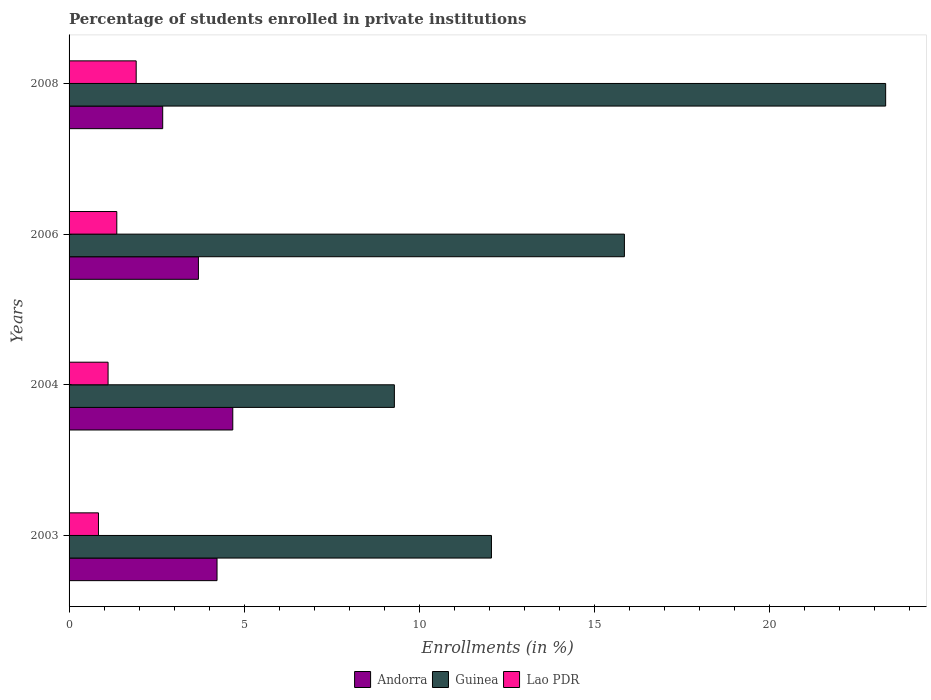Are the number of bars per tick equal to the number of legend labels?
Offer a very short reply. Yes. Are the number of bars on each tick of the Y-axis equal?
Provide a succinct answer. Yes. How many bars are there on the 1st tick from the bottom?
Ensure brevity in your answer.  3. What is the label of the 2nd group of bars from the top?
Your answer should be very brief. 2006. What is the percentage of trained teachers in Andorra in 2006?
Keep it short and to the point. 3.7. Across all years, what is the maximum percentage of trained teachers in Guinea?
Your answer should be compact. 23.33. Across all years, what is the minimum percentage of trained teachers in Lao PDR?
Keep it short and to the point. 0.84. In which year was the percentage of trained teachers in Lao PDR maximum?
Offer a terse response. 2008. What is the total percentage of trained teachers in Andorra in the graph?
Offer a very short reply. 15.27. What is the difference between the percentage of trained teachers in Guinea in 2003 and that in 2008?
Ensure brevity in your answer.  -11.26. What is the difference between the percentage of trained teachers in Andorra in 2008 and the percentage of trained teachers in Lao PDR in 2003?
Your answer should be very brief. 1.83. What is the average percentage of trained teachers in Andorra per year?
Your answer should be very brief. 3.82. In the year 2008, what is the difference between the percentage of trained teachers in Andorra and percentage of trained teachers in Lao PDR?
Your answer should be very brief. 0.76. What is the ratio of the percentage of trained teachers in Guinea in 2004 to that in 2006?
Provide a short and direct response. 0.59. Is the percentage of trained teachers in Andorra in 2004 less than that in 2006?
Offer a terse response. No. Is the difference between the percentage of trained teachers in Andorra in 2003 and 2004 greater than the difference between the percentage of trained teachers in Lao PDR in 2003 and 2004?
Give a very brief answer. No. What is the difference between the highest and the second highest percentage of trained teachers in Andorra?
Ensure brevity in your answer.  0.45. What is the difference between the highest and the lowest percentage of trained teachers in Guinea?
Provide a short and direct response. 14.03. Is the sum of the percentage of trained teachers in Lao PDR in 2003 and 2008 greater than the maximum percentage of trained teachers in Guinea across all years?
Your answer should be very brief. No. What does the 3rd bar from the top in 2006 represents?
Your answer should be compact. Andorra. What does the 3rd bar from the bottom in 2006 represents?
Ensure brevity in your answer.  Lao PDR. How many bars are there?
Ensure brevity in your answer.  12. How many years are there in the graph?
Offer a terse response. 4. What is the difference between two consecutive major ticks on the X-axis?
Provide a short and direct response. 5. Are the values on the major ticks of X-axis written in scientific E-notation?
Your answer should be compact. No. Does the graph contain any zero values?
Offer a very short reply. No. How many legend labels are there?
Your response must be concise. 3. How are the legend labels stacked?
Keep it short and to the point. Horizontal. What is the title of the graph?
Your answer should be very brief. Percentage of students enrolled in private institutions. Does "Ecuador" appear as one of the legend labels in the graph?
Your response must be concise. No. What is the label or title of the X-axis?
Offer a terse response. Enrollments (in %). What is the label or title of the Y-axis?
Make the answer very short. Years. What is the Enrollments (in %) of Andorra in 2003?
Offer a terse response. 4.23. What is the Enrollments (in %) of Guinea in 2003?
Your response must be concise. 12.07. What is the Enrollments (in %) in Lao PDR in 2003?
Offer a terse response. 0.84. What is the Enrollments (in %) in Andorra in 2004?
Your answer should be compact. 4.68. What is the Enrollments (in %) of Guinea in 2004?
Offer a very short reply. 9.29. What is the Enrollments (in %) of Lao PDR in 2004?
Your answer should be compact. 1.11. What is the Enrollments (in %) of Andorra in 2006?
Your answer should be very brief. 3.7. What is the Enrollments (in %) in Guinea in 2006?
Make the answer very short. 15.86. What is the Enrollments (in %) of Lao PDR in 2006?
Offer a very short reply. 1.36. What is the Enrollments (in %) in Andorra in 2008?
Make the answer very short. 2.67. What is the Enrollments (in %) of Guinea in 2008?
Offer a very short reply. 23.33. What is the Enrollments (in %) of Lao PDR in 2008?
Provide a succinct answer. 1.92. Across all years, what is the maximum Enrollments (in %) in Andorra?
Make the answer very short. 4.68. Across all years, what is the maximum Enrollments (in %) in Guinea?
Offer a terse response. 23.33. Across all years, what is the maximum Enrollments (in %) in Lao PDR?
Your answer should be very brief. 1.92. Across all years, what is the minimum Enrollments (in %) of Andorra?
Your response must be concise. 2.67. Across all years, what is the minimum Enrollments (in %) of Guinea?
Offer a very short reply. 9.29. Across all years, what is the minimum Enrollments (in %) of Lao PDR?
Offer a terse response. 0.84. What is the total Enrollments (in %) of Andorra in the graph?
Your answer should be compact. 15.27. What is the total Enrollments (in %) of Guinea in the graph?
Keep it short and to the point. 60.55. What is the total Enrollments (in %) in Lao PDR in the graph?
Make the answer very short. 5.23. What is the difference between the Enrollments (in %) of Andorra in 2003 and that in 2004?
Offer a very short reply. -0.45. What is the difference between the Enrollments (in %) of Guinea in 2003 and that in 2004?
Your response must be concise. 2.77. What is the difference between the Enrollments (in %) in Lao PDR in 2003 and that in 2004?
Keep it short and to the point. -0.27. What is the difference between the Enrollments (in %) in Andorra in 2003 and that in 2006?
Your answer should be very brief. 0.53. What is the difference between the Enrollments (in %) of Guinea in 2003 and that in 2006?
Ensure brevity in your answer.  -3.8. What is the difference between the Enrollments (in %) in Lao PDR in 2003 and that in 2006?
Offer a terse response. -0.52. What is the difference between the Enrollments (in %) in Andorra in 2003 and that in 2008?
Your answer should be very brief. 1.55. What is the difference between the Enrollments (in %) in Guinea in 2003 and that in 2008?
Give a very brief answer. -11.26. What is the difference between the Enrollments (in %) of Lao PDR in 2003 and that in 2008?
Give a very brief answer. -1.08. What is the difference between the Enrollments (in %) in Andorra in 2004 and that in 2006?
Keep it short and to the point. 0.98. What is the difference between the Enrollments (in %) in Guinea in 2004 and that in 2006?
Provide a succinct answer. -6.57. What is the difference between the Enrollments (in %) of Lao PDR in 2004 and that in 2006?
Give a very brief answer. -0.25. What is the difference between the Enrollments (in %) in Andorra in 2004 and that in 2008?
Keep it short and to the point. 2. What is the difference between the Enrollments (in %) of Guinea in 2004 and that in 2008?
Offer a very short reply. -14.03. What is the difference between the Enrollments (in %) in Lao PDR in 2004 and that in 2008?
Give a very brief answer. -0.8. What is the difference between the Enrollments (in %) of Andorra in 2006 and that in 2008?
Your response must be concise. 1.02. What is the difference between the Enrollments (in %) in Guinea in 2006 and that in 2008?
Offer a terse response. -7.46. What is the difference between the Enrollments (in %) in Lao PDR in 2006 and that in 2008?
Your answer should be compact. -0.55. What is the difference between the Enrollments (in %) in Andorra in 2003 and the Enrollments (in %) in Guinea in 2004?
Offer a very short reply. -5.07. What is the difference between the Enrollments (in %) of Andorra in 2003 and the Enrollments (in %) of Lao PDR in 2004?
Your answer should be compact. 3.11. What is the difference between the Enrollments (in %) in Guinea in 2003 and the Enrollments (in %) in Lao PDR in 2004?
Provide a short and direct response. 10.95. What is the difference between the Enrollments (in %) in Andorra in 2003 and the Enrollments (in %) in Guinea in 2006?
Give a very brief answer. -11.64. What is the difference between the Enrollments (in %) of Andorra in 2003 and the Enrollments (in %) of Lao PDR in 2006?
Your answer should be compact. 2.86. What is the difference between the Enrollments (in %) of Guinea in 2003 and the Enrollments (in %) of Lao PDR in 2006?
Your response must be concise. 10.7. What is the difference between the Enrollments (in %) in Andorra in 2003 and the Enrollments (in %) in Guinea in 2008?
Give a very brief answer. -19.1. What is the difference between the Enrollments (in %) in Andorra in 2003 and the Enrollments (in %) in Lao PDR in 2008?
Your answer should be compact. 2.31. What is the difference between the Enrollments (in %) in Guinea in 2003 and the Enrollments (in %) in Lao PDR in 2008?
Provide a succinct answer. 10.15. What is the difference between the Enrollments (in %) of Andorra in 2004 and the Enrollments (in %) of Guinea in 2006?
Your response must be concise. -11.19. What is the difference between the Enrollments (in %) of Andorra in 2004 and the Enrollments (in %) of Lao PDR in 2006?
Your answer should be very brief. 3.31. What is the difference between the Enrollments (in %) in Guinea in 2004 and the Enrollments (in %) in Lao PDR in 2006?
Give a very brief answer. 7.93. What is the difference between the Enrollments (in %) of Andorra in 2004 and the Enrollments (in %) of Guinea in 2008?
Your response must be concise. -18.65. What is the difference between the Enrollments (in %) of Andorra in 2004 and the Enrollments (in %) of Lao PDR in 2008?
Your answer should be compact. 2.76. What is the difference between the Enrollments (in %) of Guinea in 2004 and the Enrollments (in %) of Lao PDR in 2008?
Give a very brief answer. 7.38. What is the difference between the Enrollments (in %) of Andorra in 2006 and the Enrollments (in %) of Guinea in 2008?
Offer a very short reply. -19.63. What is the difference between the Enrollments (in %) of Andorra in 2006 and the Enrollments (in %) of Lao PDR in 2008?
Provide a short and direct response. 1.78. What is the difference between the Enrollments (in %) of Guinea in 2006 and the Enrollments (in %) of Lao PDR in 2008?
Offer a very short reply. 13.95. What is the average Enrollments (in %) in Andorra per year?
Make the answer very short. 3.82. What is the average Enrollments (in %) in Guinea per year?
Offer a very short reply. 15.14. What is the average Enrollments (in %) of Lao PDR per year?
Offer a terse response. 1.31. In the year 2003, what is the difference between the Enrollments (in %) in Andorra and Enrollments (in %) in Guinea?
Offer a terse response. -7.84. In the year 2003, what is the difference between the Enrollments (in %) of Andorra and Enrollments (in %) of Lao PDR?
Offer a terse response. 3.39. In the year 2003, what is the difference between the Enrollments (in %) in Guinea and Enrollments (in %) in Lao PDR?
Give a very brief answer. 11.23. In the year 2004, what is the difference between the Enrollments (in %) of Andorra and Enrollments (in %) of Guinea?
Make the answer very short. -4.62. In the year 2004, what is the difference between the Enrollments (in %) in Andorra and Enrollments (in %) in Lao PDR?
Keep it short and to the point. 3.56. In the year 2004, what is the difference between the Enrollments (in %) in Guinea and Enrollments (in %) in Lao PDR?
Your answer should be very brief. 8.18. In the year 2006, what is the difference between the Enrollments (in %) of Andorra and Enrollments (in %) of Guinea?
Provide a succinct answer. -12.17. In the year 2006, what is the difference between the Enrollments (in %) of Andorra and Enrollments (in %) of Lao PDR?
Keep it short and to the point. 2.33. In the year 2006, what is the difference between the Enrollments (in %) of Guinea and Enrollments (in %) of Lao PDR?
Provide a succinct answer. 14.5. In the year 2008, what is the difference between the Enrollments (in %) in Andorra and Enrollments (in %) in Guinea?
Your answer should be compact. -20.65. In the year 2008, what is the difference between the Enrollments (in %) in Andorra and Enrollments (in %) in Lao PDR?
Your response must be concise. 0.76. In the year 2008, what is the difference between the Enrollments (in %) of Guinea and Enrollments (in %) of Lao PDR?
Provide a succinct answer. 21.41. What is the ratio of the Enrollments (in %) of Andorra in 2003 to that in 2004?
Provide a short and direct response. 0.9. What is the ratio of the Enrollments (in %) in Guinea in 2003 to that in 2004?
Provide a succinct answer. 1.3. What is the ratio of the Enrollments (in %) of Lao PDR in 2003 to that in 2004?
Your answer should be very brief. 0.75. What is the ratio of the Enrollments (in %) in Andorra in 2003 to that in 2006?
Provide a succinct answer. 1.14. What is the ratio of the Enrollments (in %) of Guinea in 2003 to that in 2006?
Make the answer very short. 0.76. What is the ratio of the Enrollments (in %) of Lao PDR in 2003 to that in 2006?
Your answer should be very brief. 0.62. What is the ratio of the Enrollments (in %) in Andorra in 2003 to that in 2008?
Ensure brevity in your answer.  1.58. What is the ratio of the Enrollments (in %) of Guinea in 2003 to that in 2008?
Offer a very short reply. 0.52. What is the ratio of the Enrollments (in %) in Lao PDR in 2003 to that in 2008?
Your answer should be very brief. 0.44. What is the ratio of the Enrollments (in %) of Andorra in 2004 to that in 2006?
Ensure brevity in your answer.  1.27. What is the ratio of the Enrollments (in %) of Guinea in 2004 to that in 2006?
Provide a succinct answer. 0.59. What is the ratio of the Enrollments (in %) in Lao PDR in 2004 to that in 2006?
Offer a terse response. 0.82. What is the ratio of the Enrollments (in %) in Andorra in 2004 to that in 2008?
Ensure brevity in your answer.  1.75. What is the ratio of the Enrollments (in %) in Guinea in 2004 to that in 2008?
Your response must be concise. 0.4. What is the ratio of the Enrollments (in %) of Lao PDR in 2004 to that in 2008?
Make the answer very short. 0.58. What is the ratio of the Enrollments (in %) of Andorra in 2006 to that in 2008?
Your answer should be compact. 1.38. What is the ratio of the Enrollments (in %) in Guinea in 2006 to that in 2008?
Make the answer very short. 0.68. What is the ratio of the Enrollments (in %) of Lao PDR in 2006 to that in 2008?
Your response must be concise. 0.71. What is the difference between the highest and the second highest Enrollments (in %) of Andorra?
Ensure brevity in your answer.  0.45. What is the difference between the highest and the second highest Enrollments (in %) in Guinea?
Ensure brevity in your answer.  7.46. What is the difference between the highest and the second highest Enrollments (in %) in Lao PDR?
Offer a terse response. 0.55. What is the difference between the highest and the lowest Enrollments (in %) of Andorra?
Ensure brevity in your answer.  2. What is the difference between the highest and the lowest Enrollments (in %) in Guinea?
Make the answer very short. 14.03. What is the difference between the highest and the lowest Enrollments (in %) of Lao PDR?
Offer a terse response. 1.08. 